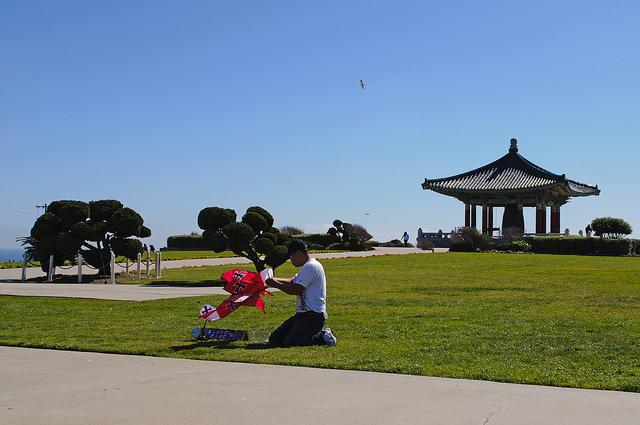What is the man kneeling going to do next? fly kite 